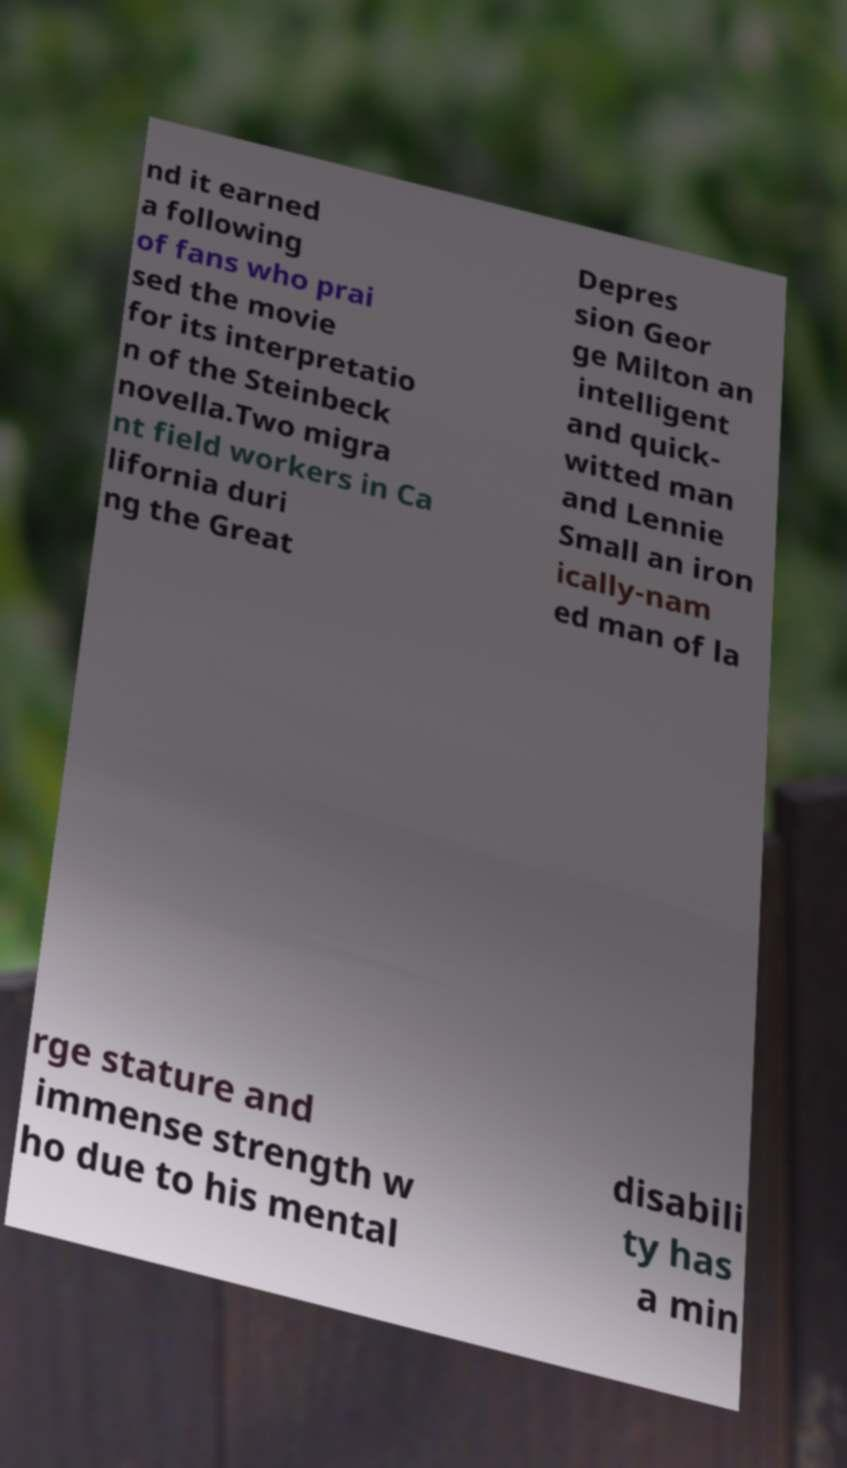Please read and relay the text visible in this image. What does it say? nd it earned a following of fans who prai sed the movie for its interpretatio n of the Steinbeck novella.Two migra nt field workers in Ca lifornia duri ng the Great Depres sion Geor ge Milton an intelligent and quick- witted man and Lennie Small an iron ically-nam ed man of la rge stature and immense strength w ho due to his mental disabili ty has a min 